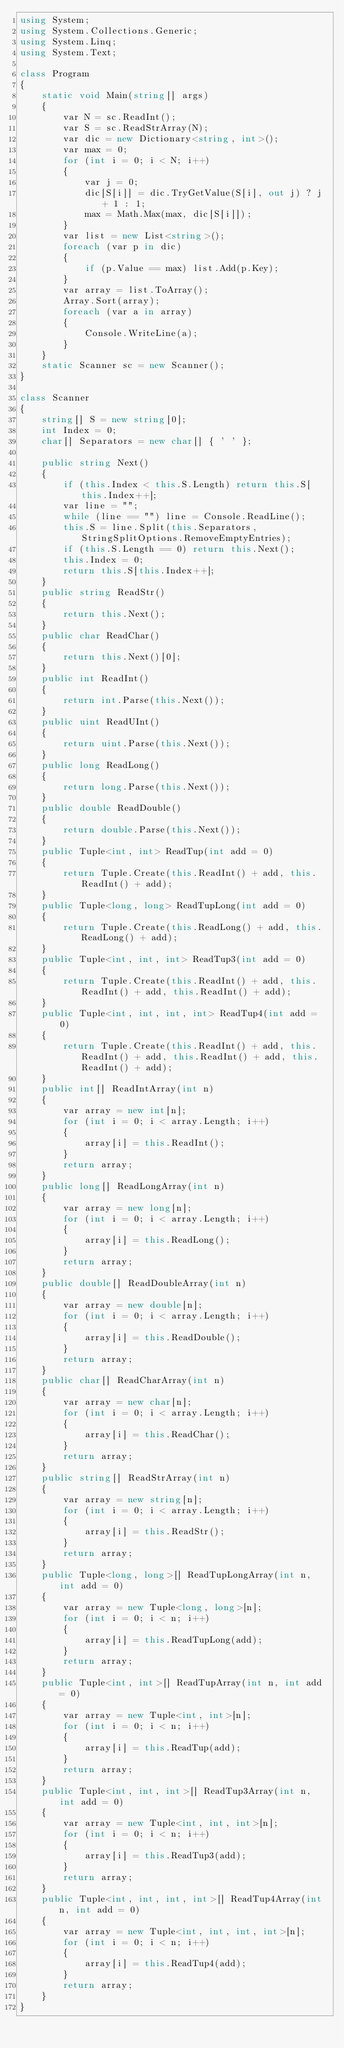<code> <loc_0><loc_0><loc_500><loc_500><_C#_>using System;
using System.Collections.Generic;
using System.Linq;
using System.Text;

class Program
{
    static void Main(string[] args)
    {
        var N = sc.ReadInt();
        var S = sc.ReadStrArray(N);
        var dic = new Dictionary<string, int>();
        var max = 0;
        for (int i = 0; i < N; i++)
        {
            var j = 0;
            dic[S[i]] = dic.TryGetValue(S[i], out j) ? j + 1 : 1;
            max = Math.Max(max, dic[S[i]]);
        }
        var list = new List<string>();
        foreach (var p in dic)
        {
            if (p.Value == max) list.Add(p.Key);
        }
        var array = list.ToArray();
        Array.Sort(array);
        foreach (var a in array)
        {
            Console.WriteLine(a);
        }
    }
    static Scanner sc = new Scanner();
}

class Scanner
{
    string[] S = new string[0];
    int Index = 0;
    char[] Separators = new char[] { ' ' };

    public string Next()
    {
        if (this.Index < this.S.Length) return this.S[this.Index++];
        var line = "";
        while (line == "") line = Console.ReadLine();
        this.S = line.Split(this.Separators, StringSplitOptions.RemoveEmptyEntries);
        if (this.S.Length == 0) return this.Next();
        this.Index = 0;
        return this.S[this.Index++];
    }
    public string ReadStr()
    {
        return this.Next();
    }
    public char ReadChar()
    {
        return this.Next()[0];
    }
    public int ReadInt()
    {
        return int.Parse(this.Next());
    }
    public uint ReadUInt()
    {
        return uint.Parse(this.Next());
    }
    public long ReadLong()
    {
        return long.Parse(this.Next());
    }
    public double ReadDouble()
    {
        return double.Parse(this.Next());
    }
    public Tuple<int, int> ReadTup(int add = 0)
    {
        return Tuple.Create(this.ReadInt() + add, this.ReadInt() + add);
    }
    public Tuple<long, long> ReadTupLong(int add = 0)
    {
        return Tuple.Create(this.ReadLong() + add, this.ReadLong() + add);
    }
    public Tuple<int, int, int> ReadTup3(int add = 0)
    {
        return Tuple.Create(this.ReadInt() + add, this.ReadInt() + add, this.ReadInt() + add);
    }
    public Tuple<int, int, int, int> ReadTup4(int add = 0)
    {
        return Tuple.Create(this.ReadInt() + add, this.ReadInt() + add, this.ReadInt() + add, this.ReadInt() + add);
    }
    public int[] ReadIntArray(int n)
    {
        var array = new int[n];
        for (int i = 0; i < array.Length; i++)
        {
            array[i] = this.ReadInt();
        }
        return array;
    }
    public long[] ReadLongArray(int n)
    {
        var array = new long[n];
        for (int i = 0; i < array.Length; i++)
        {
            array[i] = this.ReadLong();
        }
        return array;
    }
    public double[] ReadDoubleArray(int n)
    {
        var array = new double[n];
        for (int i = 0; i < array.Length; i++)
        {
            array[i] = this.ReadDouble();
        }
        return array;
    }
    public char[] ReadCharArray(int n)
    {
        var array = new char[n];
        for (int i = 0; i < array.Length; i++)
        {
            array[i] = this.ReadChar();
        }
        return array;
    }
    public string[] ReadStrArray(int n)
    {
        var array = new string[n];
        for (int i = 0; i < array.Length; i++)
        {
            array[i] = this.ReadStr();
        }
        return array;
    }
    public Tuple<long, long>[] ReadTupLongArray(int n, int add = 0)
    {
        var array = new Tuple<long, long>[n];
        for (int i = 0; i < n; i++)
        {
            array[i] = this.ReadTupLong(add);
        }
        return array;
    }
    public Tuple<int, int>[] ReadTupArray(int n, int add = 0)
    {
        var array = new Tuple<int, int>[n];
        for (int i = 0; i < n; i++)
        {
            array[i] = this.ReadTup(add);
        }
        return array;
    }
    public Tuple<int, int, int>[] ReadTup3Array(int n, int add = 0)
    {
        var array = new Tuple<int, int, int>[n];
        for (int i = 0; i < n; i++)
        {
            array[i] = this.ReadTup3(add);
        }
        return array;
    }
    public Tuple<int, int, int, int>[] ReadTup4Array(int n, int add = 0)
    {
        var array = new Tuple<int, int, int, int>[n];
        for (int i = 0; i < n; i++)
        {
            array[i] = this.ReadTup4(add);
        }
        return array;
    }
}
</code> 